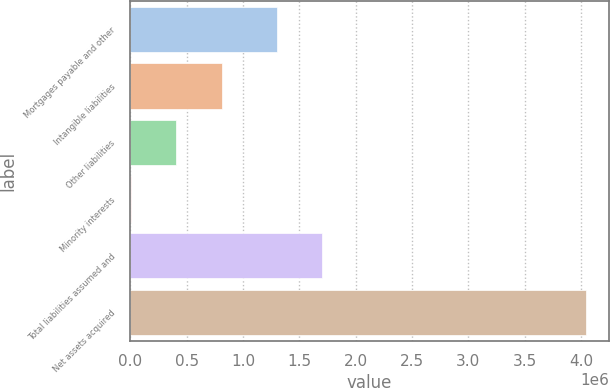Convert chart. <chart><loc_0><loc_0><loc_500><loc_500><bar_chart><fcel>Mortgages payable and other<fcel>Intangible liabilities<fcel>Other liabilities<fcel>Minority interests<fcel>Total liabilities assumed and<fcel>Net assets acquired<nl><fcel>1.29911e+06<fcel>813295<fcel>409278<fcel>5261<fcel>1.70313e+06<fcel>4.04543e+06<nl></chart> 